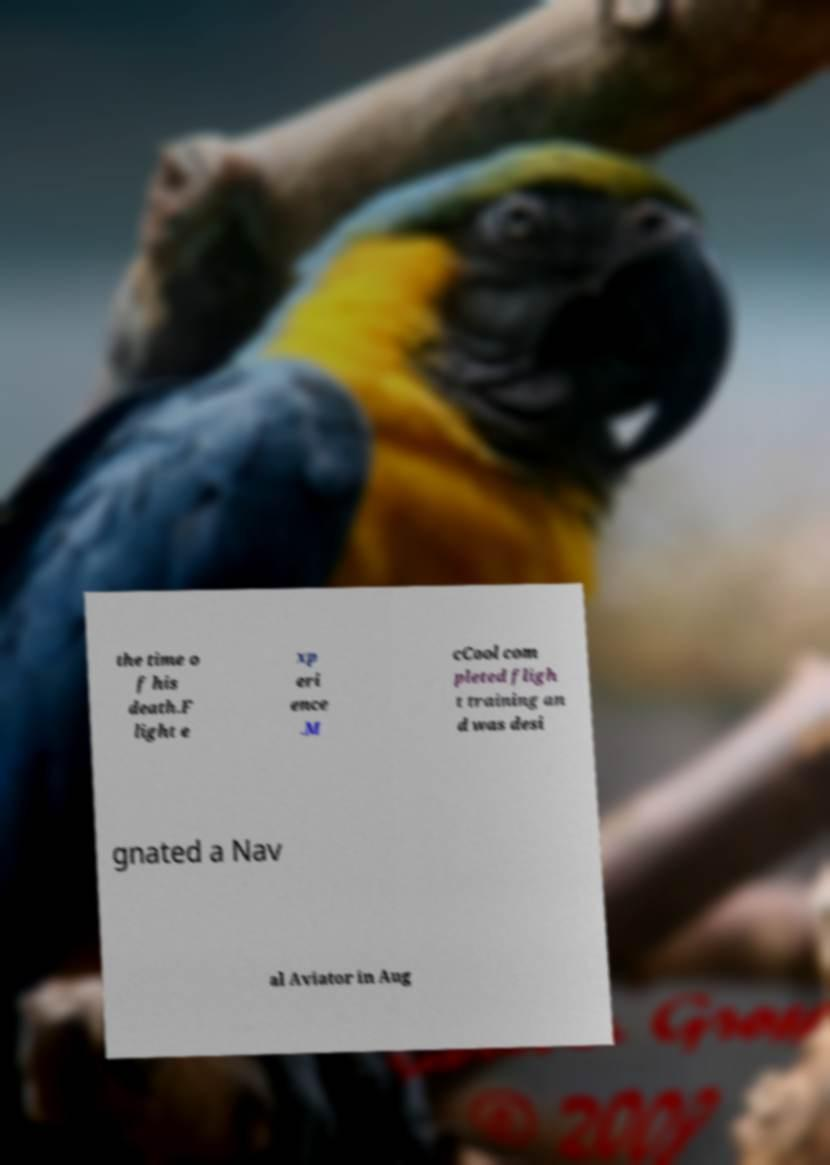What messages or text are displayed in this image? I need them in a readable, typed format. the time o f his death.F light e xp eri ence .M cCool com pleted fligh t training an d was desi gnated a Nav al Aviator in Aug 